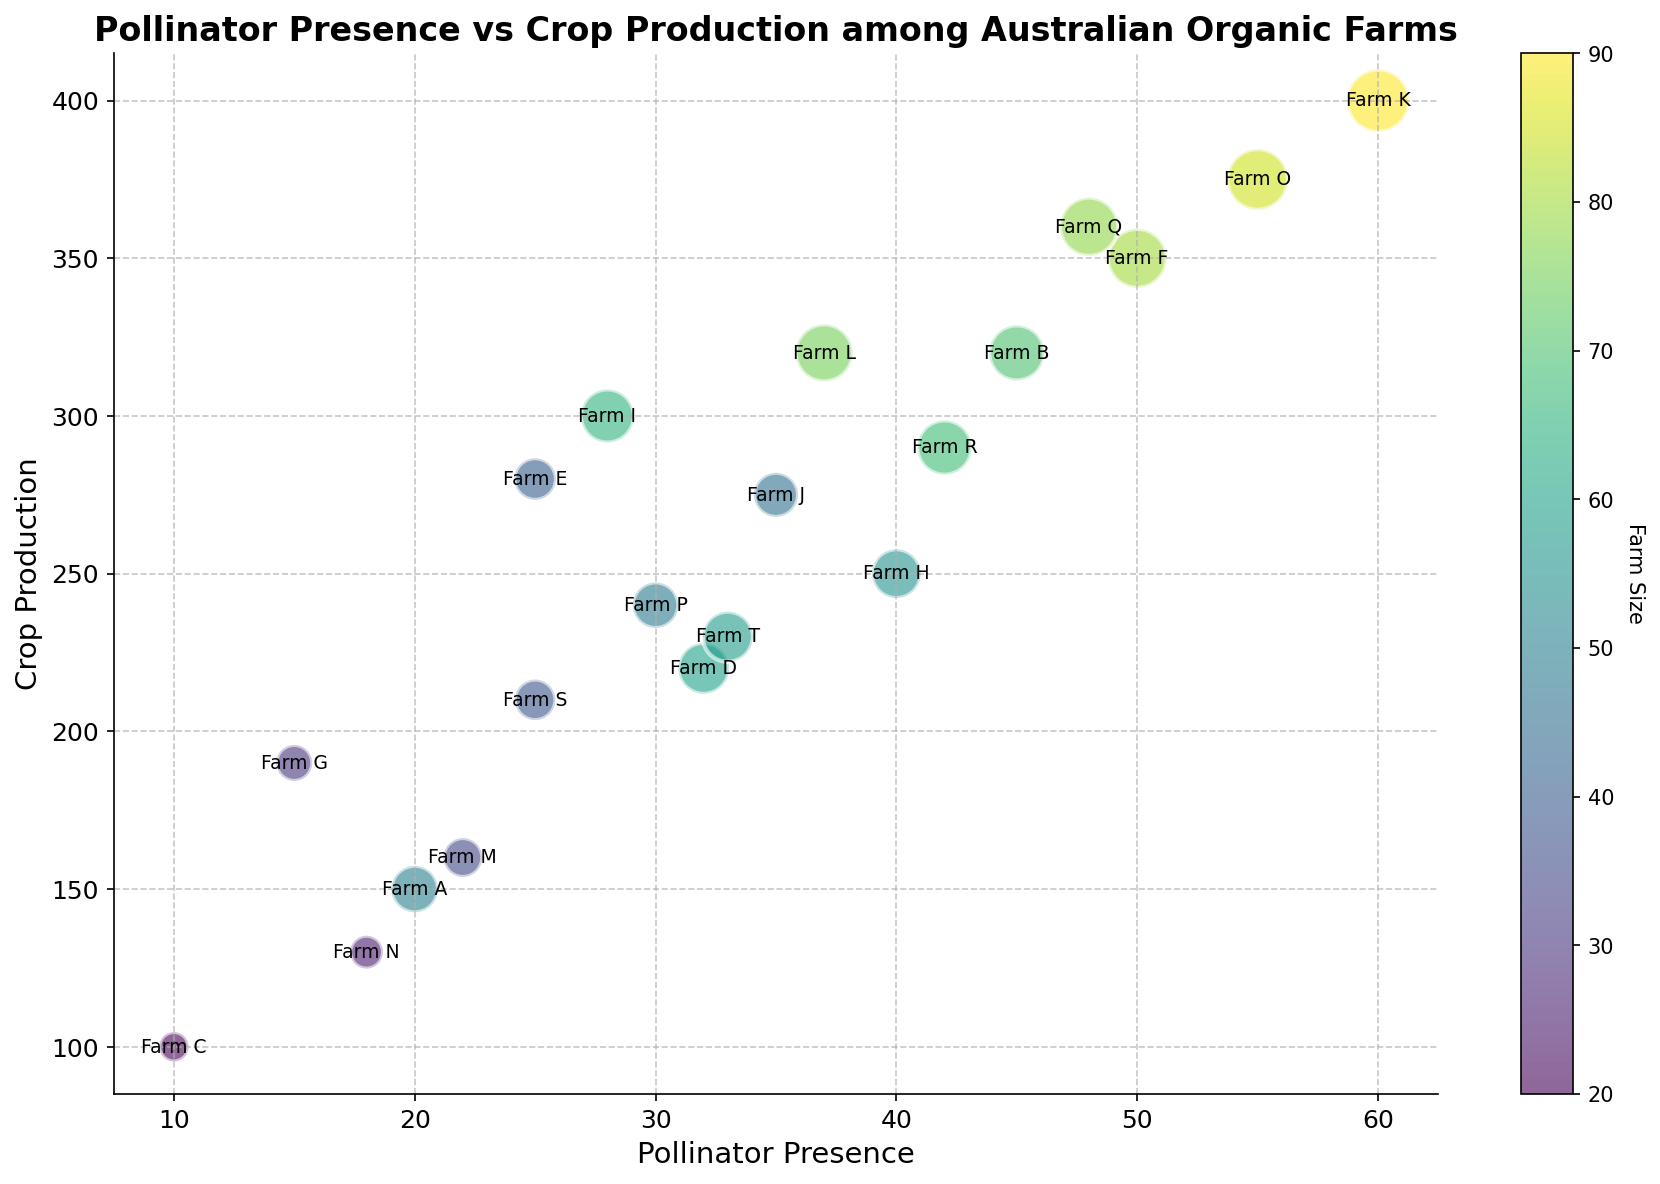What's the farm with the highest crop production? To determine the farm with the highest crop production, look for the highest point on the y-axis. Farm K has the highest value at 400.
Answer: Farm K What is the average pollinator presence across all farms? Add up all the pollinator presence values (20 + 45 + 10 + 32 + 25 + 50 + 15 + 40 + 28 + 35 + 60 + 37 + 22 + 18 + 55 + 30 + 48 + 42 + 25 + 33 = 670). Divide by the number of farms (20). The average is 670/20 = 33.5.
Answer: 33.5 Which farm has a higher crop production, Farm B or Farm F? Compare the y-values for Farm B (320) and Farm F (350). Farm F has a higher crop production.
Answer: Farm F What is the total crop production for Farm D and Farm E? Add the crop production values for Farm D (220) and Farm E (280). The total is 220 + 280 = 500.
Answer: 500 Between Farm T and Farm H, which farm has more pollinator presence and by how much? Compare the x-values for Farm T (33) and Farm H (40). Farm H has more pollinator presence. The difference is 40 - 33 = 7.
Answer: Farm H, 7 Which farm has the smallest bubble and what does it represent? The smallest bubbles represent the smallest farm sizes. The smallest bubble belongs to Farm C, which has a size value of 20.
Answer: Farm C Is there any farm with exactly 50 pollinator presence and how much is their crop production? Look for a point on the x-axis that corresponds to 50 pollinator presence, which is Farm F. Its crop production value is 350.
Answer: 350 Which color represents the largest farm and what is its farm size? The bubble with the largest size is Farm K, representing the largest farm size of 90. The color can be identified from the color bar on the side of the bubble.
Answer: Farm K, 90 What is the average crop production for farms with more than 30 pollinator presence? Farms with more than 30 pollinator presence are B, D, H, I, J, K, L, O, Q, R, and T with crop productions of 320, 220, 250, 300, 275, 400, 320, 375, 360, 290, and 230 respectively. The total crop production is 3620. The average is 3620/11 = 329.1.
Answer: 329.1 